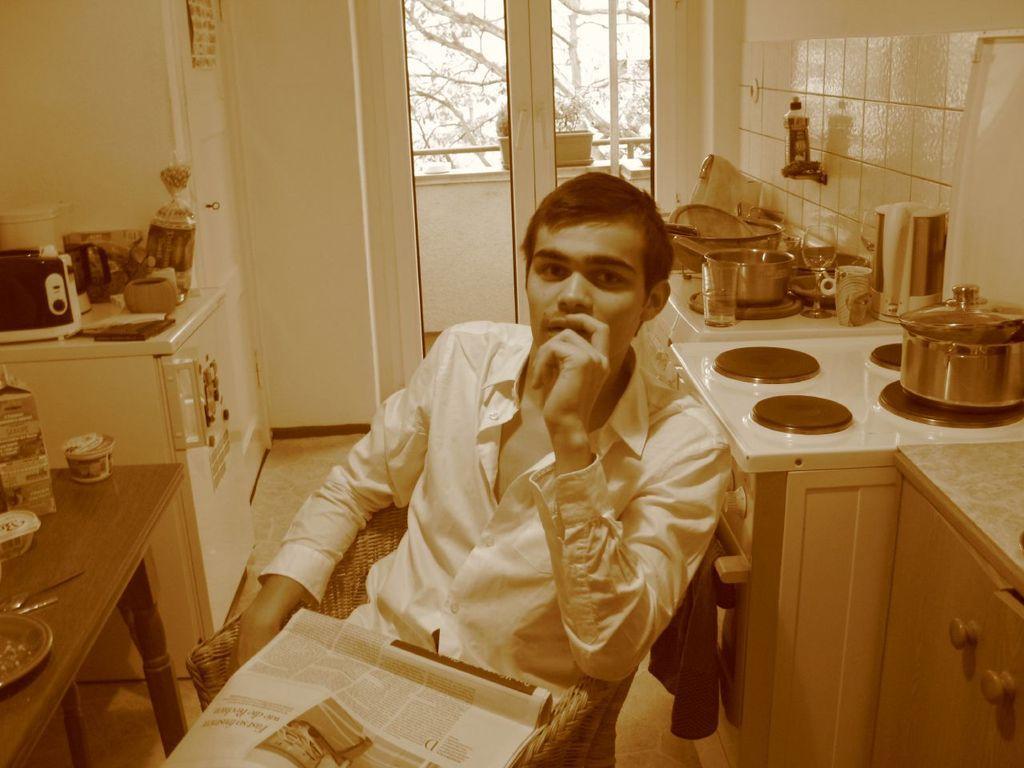In one or two sentences, can you explain what this image depicts? In the picture we can see a man sitting on the chair in the house and holding a newspaper on him and just beside him, we can see some desk, with some stove and bowls of it and on the other side, we can see a table and some items on it and in the background we can see a wall and a door with glass and to the wall we can see a tiles which are white in color. 